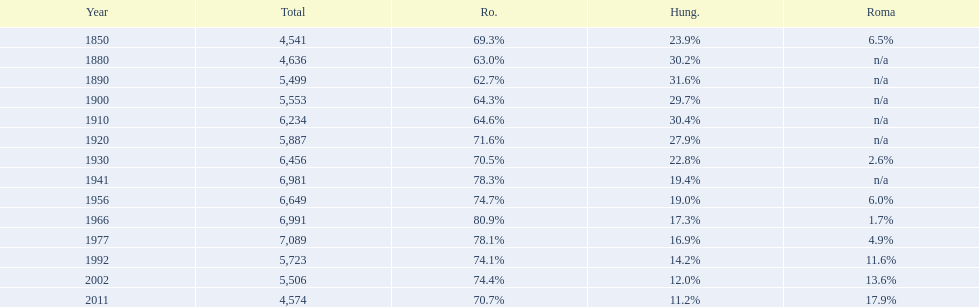In what year was there the largest percentage of hungarians? 1890. 